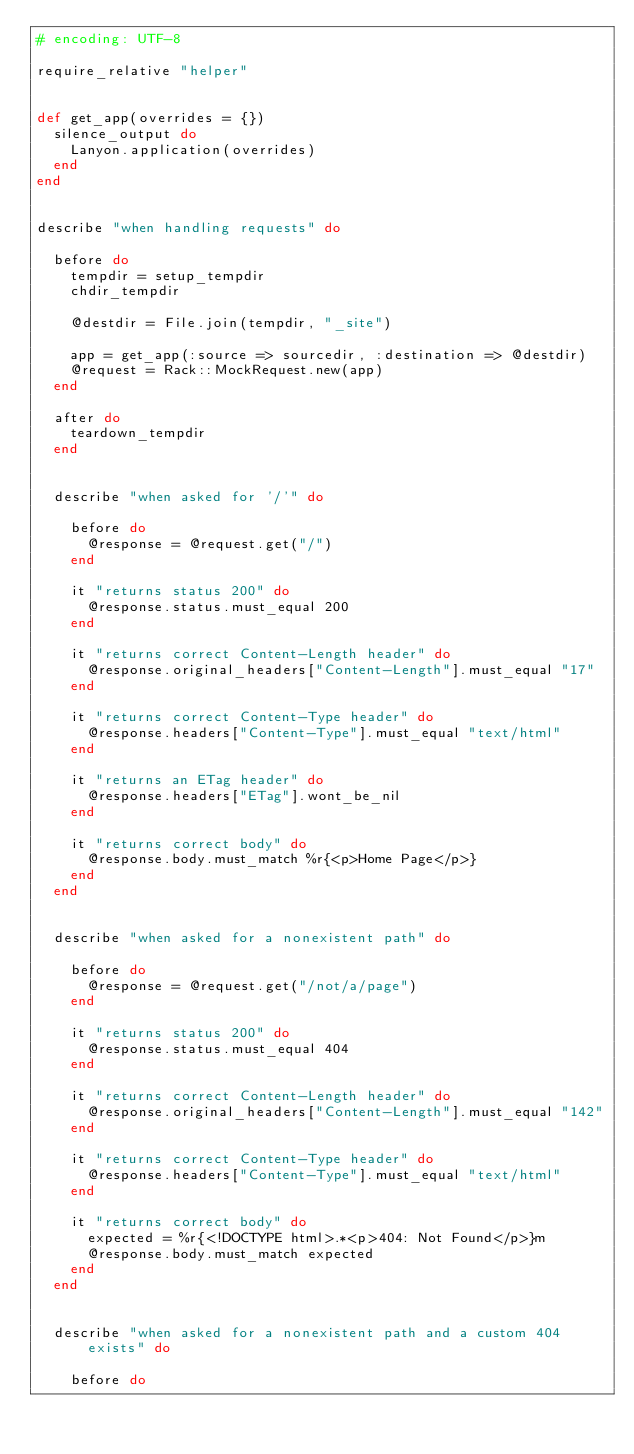Convert code to text. <code><loc_0><loc_0><loc_500><loc_500><_Ruby_># encoding: UTF-8

require_relative "helper"


def get_app(overrides = {})
  silence_output do
    Lanyon.application(overrides)
  end
end


describe "when handling requests" do

  before do
    tempdir = setup_tempdir
    chdir_tempdir

    @destdir = File.join(tempdir, "_site")

    app = get_app(:source => sourcedir, :destination => @destdir)
    @request = Rack::MockRequest.new(app)
  end

  after do
    teardown_tempdir
  end


  describe "when asked for '/'" do

    before do
      @response = @request.get("/")
    end

    it "returns status 200" do
      @response.status.must_equal 200
    end

    it "returns correct Content-Length header" do
      @response.original_headers["Content-Length"].must_equal "17"
    end

    it "returns correct Content-Type header" do
      @response.headers["Content-Type"].must_equal "text/html"
    end

    it "returns an ETag header" do
      @response.headers["ETag"].wont_be_nil
    end

    it "returns correct body" do
      @response.body.must_match %r{<p>Home Page</p>}
    end
  end


  describe "when asked for a nonexistent path" do

    before do
      @response = @request.get("/not/a/page")
    end

    it "returns status 200" do
      @response.status.must_equal 404
    end

    it "returns correct Content-Length header" do
      @response.original_headers["Content-Length"].must_equal "142"
    end

    it "returns correct Content-Type header" do
      @response.headers["Content-Type"].must_equal "text/html"
    end

    it "returns correct body" do
      expected = %r{<!DOCTYPE html>.*<p>404: Not Found</p>}m
      @response.body.must_match expected
    end
  end


  describe "when asked for a nonexistent path and a custom 404 exists" do

    before do</code> 